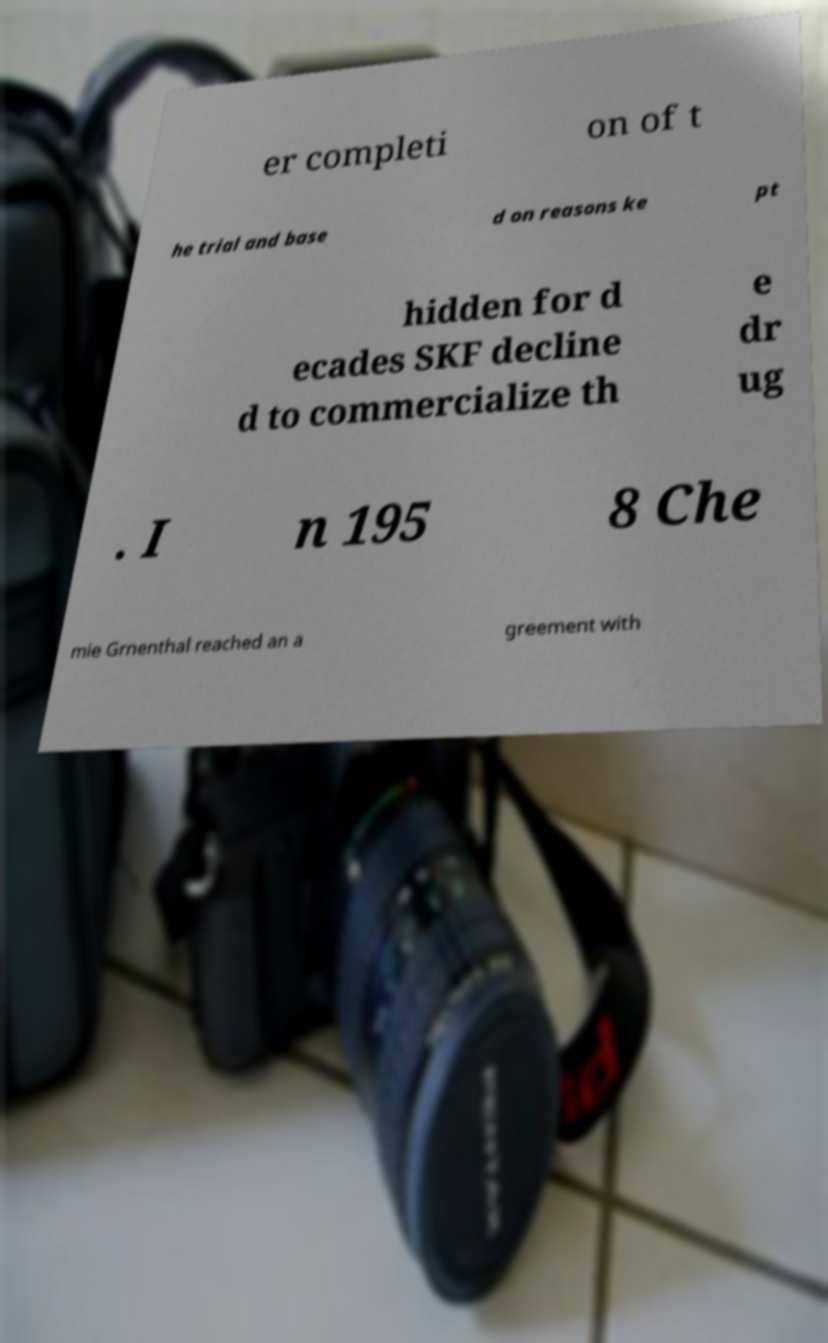Please identify and transcribe the text found in this image. er completi on of t he trial and base d on reasons ke pt hidden for d ecades SKF decline d to commercialize th e dr ug . I n 195 8 Che mie Grnenthal reached an a greement with 